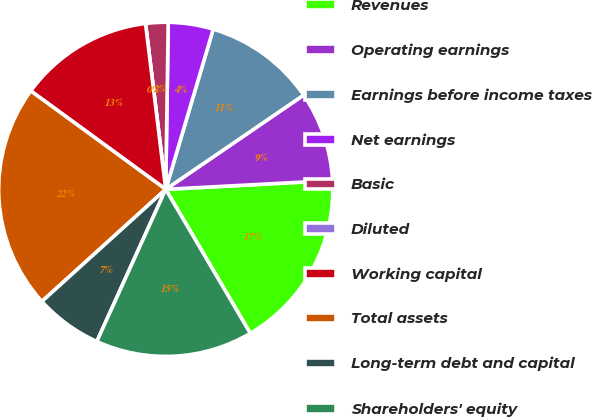Convert chart. <chart><loc_0><loc_0><loc_500><loc_500><pie_chart><fcel>Revenues<fcel>Operating earnings<fcel>Earnings before income taxes<fcel>Net earnings<fcel>Basic<fcel>Diluted<fcel>Working capital<fcel>Total assets<fcel>Long-term debt and capital<fcel>Shareholders' equity<nl><fcel>17.39%<fcel>8.7%<fcel>10.87%<fcel>4.35%<fcel>2.17%<fcel>0.0%<fcel>13.04%<fcel>21.74%<fcel>6.52%<fcel>15.22%<nl></chart> 